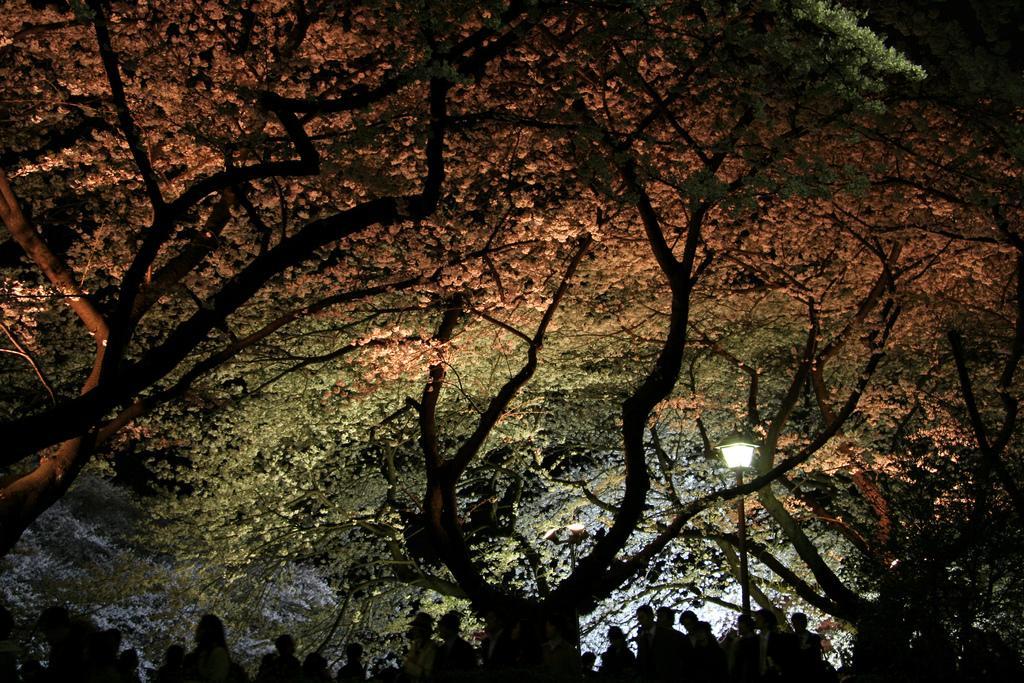Could you give a brief overview of what you see in this image? In this image I can see number of trees. On the bottom side of this image I can see number of people and on the right side I can see a pole and a light on it. 